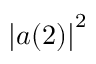Convert formula to latex. <formula><loc_0><loc_0><loc_500><loc_500>\left | a ( 2 ) \right | ^ { 2 }</formula> 